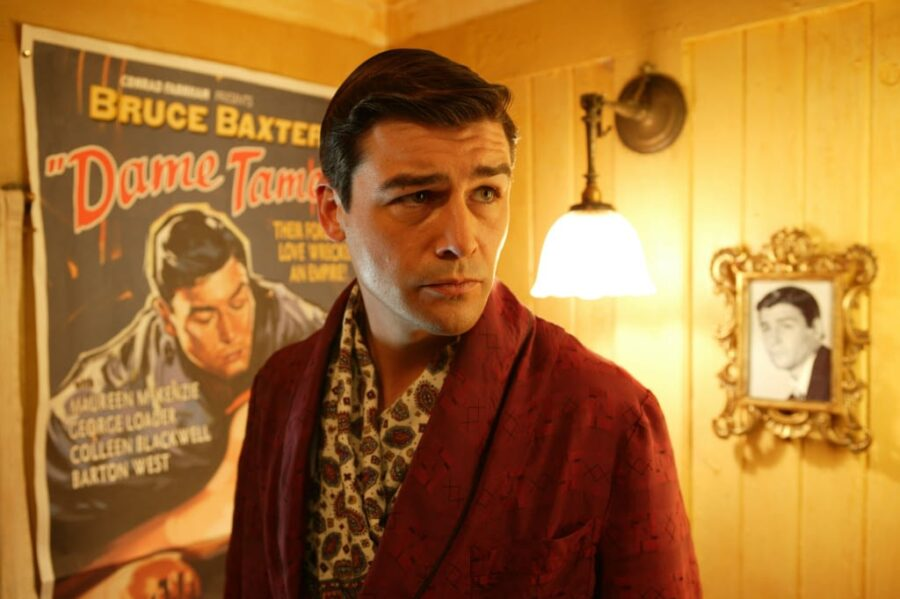What is this photo about? This photo portrays an actor dressed in a vintage-style red robe with a detailed floral pattern, giving off a classic movie star vibe. He stands before a movie poster, indicating a thematic connection to cinema, possibly in a promotional setting for a film where he plays a leading role. The setting, with its yellow walls and soft lighting from a lamp and a chandelier, enhances the nostalgic and elegant atmosphere of the scene. 